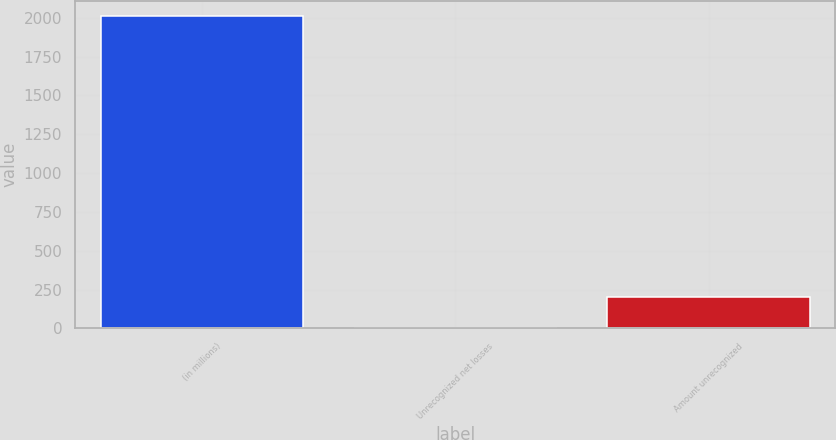<chart> <loc_0><loc_0><loc_500><loc_500><bar_chart><fcel>(in millions)<fcel>Unrecognized net losses<fcel>Amount unrecognized<nl><fcel>2011<fcel>3<fcel>203.8<nl></chart> 